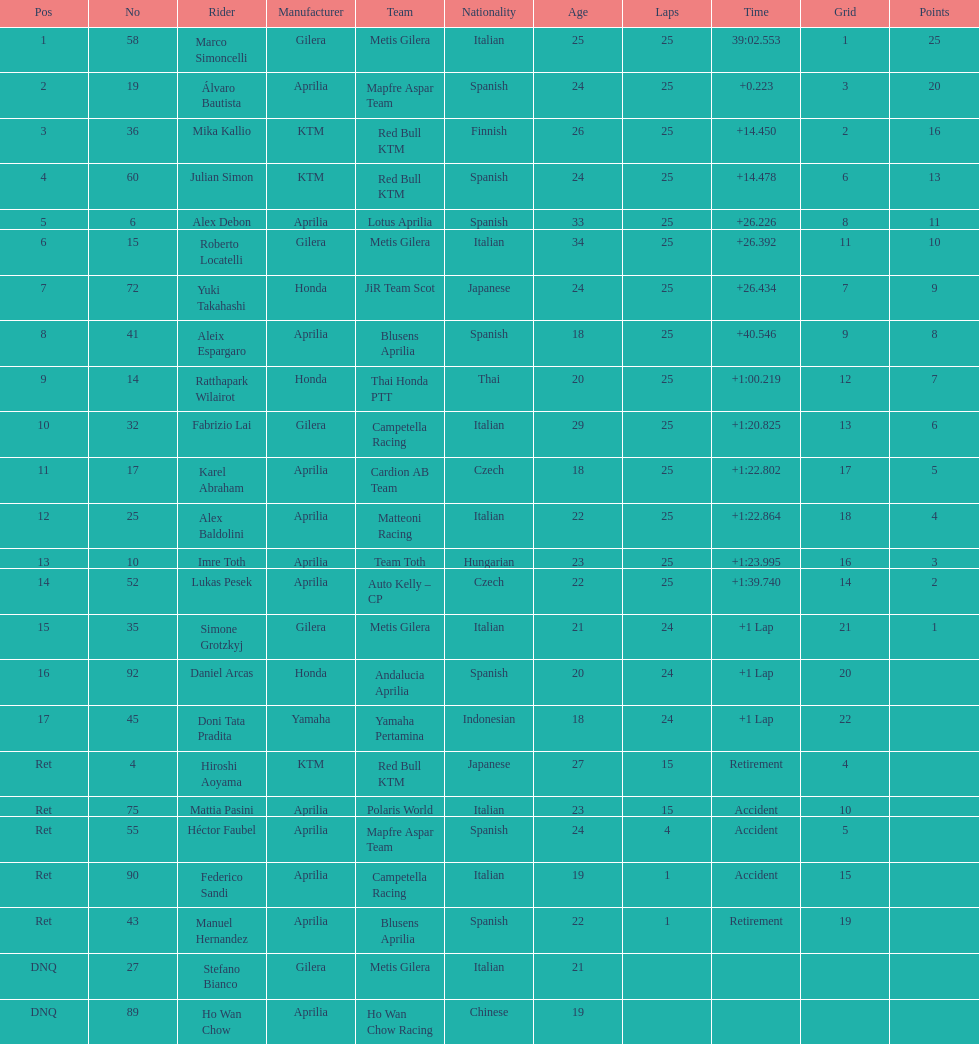The country with the most riders was Italy. 